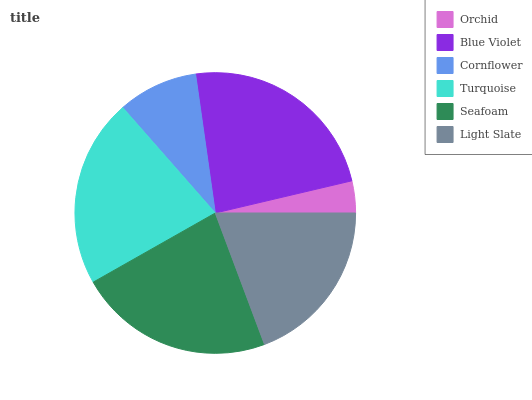Is Orchid the minimum?
Answer yes or no. Yes. Is Blue Violet the maximum?
Answer yes or no. Yes. Is Cornflower the minimum?
Answer yes or no. No. Is Cornflower the maximum?
Answer yes or no. No. Is Blue Violet greater than Cornflower?
Answer yes or no. Yes. Is Cornflower less than Blue Violet?
Answer yes or no. Yes. Is Cornflower greater than Blue Violet?
Answer yes or no. No. Is Blue Violet less than Cornflower?
Answer yes or no. No. Is Turquoise the high median?
Answer yes or no. Yes. Is Light Slate the low median?
Answer yes or no. Yes. Is Blue Violet the high median?
Answer yes or no. No. Is Turquoise the low median?
Answer yes or no. No. 